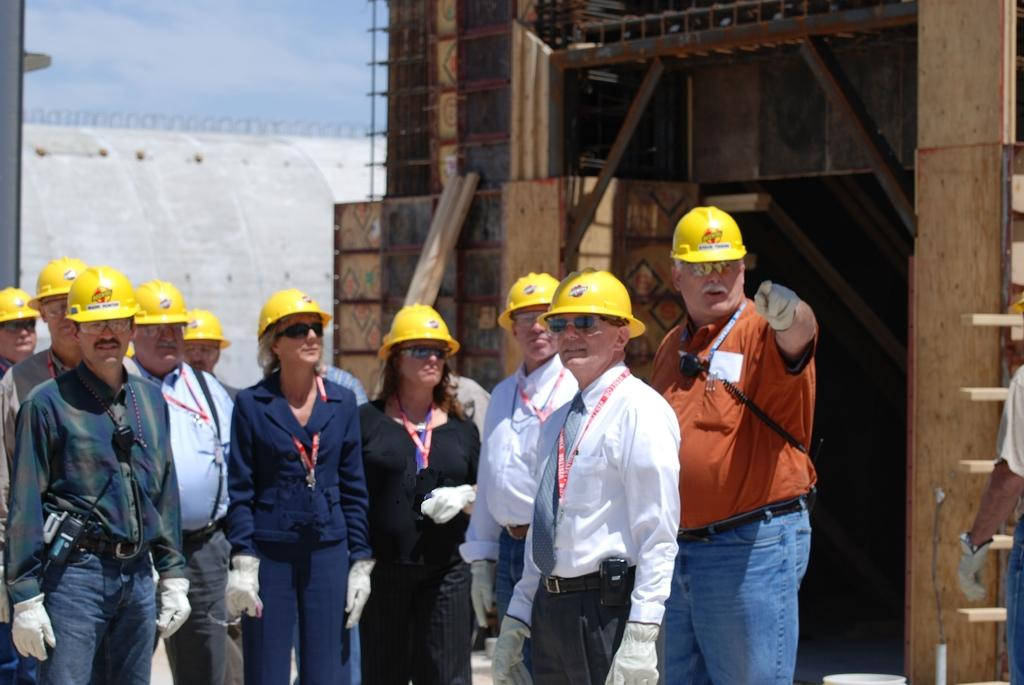How many people are in the image? There is a group of people in the image. What are the people wearing on their heads? The people are wearing yellow helmets. What can be seen in the background of the image? There is a building in the background of the image. What color is the building? The building is brown in color. What color is the sky in the image? The sky is blue in color. What type of rhythm can be heard coming from the building in the image? There is no indication of any sound or rhythm in the image, as it only shows a group of people wearing yellow helmets and a brown building in the background. 